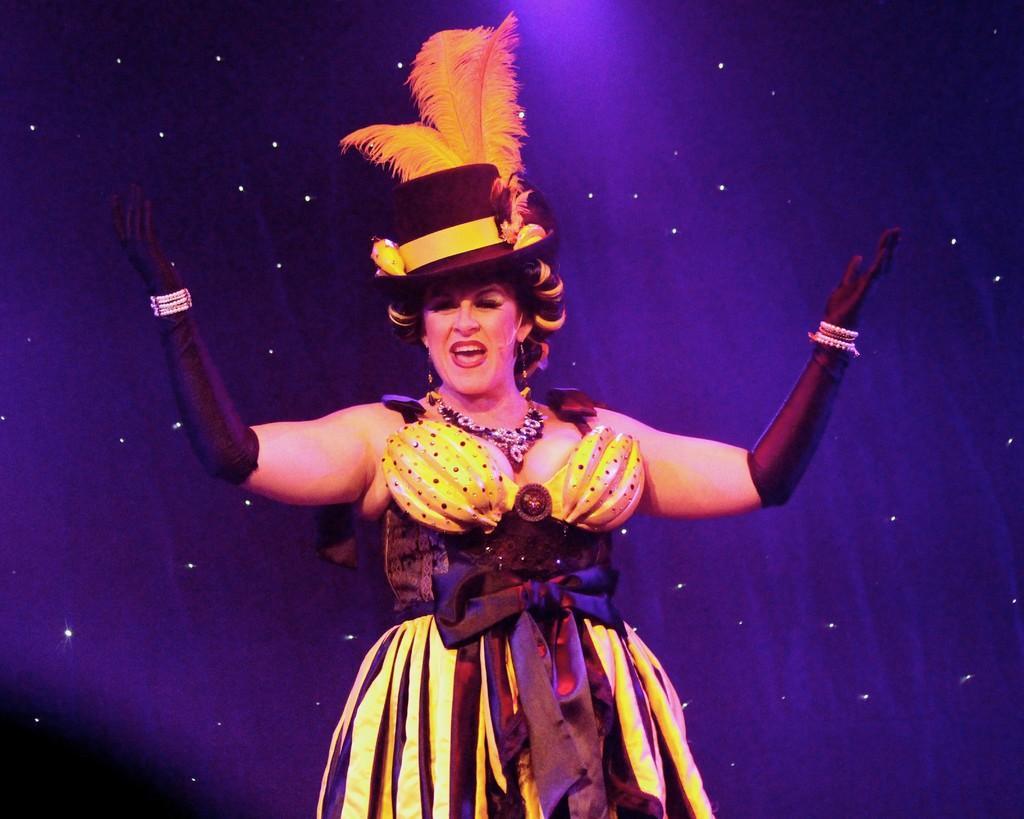Describe this image in one or two sentences. In this image there is a woman standing and smiling. In the background there are lights. 